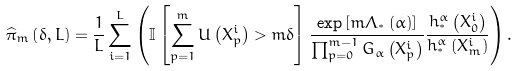Convert formula to latex. <formula><loc_0><loc_0><loc_500><loc_500>\widehat { \pi } _ { m } \left ( \delta , L \right ) = \frac { 1 } { L } \sum _ { i = 1 } ^ { L } \left ( \mathbb { I } \left [ \sum _ { p = 1 } ^ { m } U \left ( X _ { p } ^ { i } \right ) > m \delta \right ] \frac { \exp \left [ m \Lambda _ { ^ { * } } \left ( \alpha \right ) \right ] } { \prod _ { p = 0 } ^ { m - 1 } G _ { \alpha } \left ( X _ { p } ^ { i } \right ) } \frac { h _ { ^ { * } } ^ { \alpha } \left ( X _ { 0 } ^ { i } \right ) } { h _ { ^ { * } } ^ { \alpha } \left ( X _ { m } ^ { i } \right ) } \right ) .</formula> 